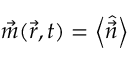Convert formula to latex. <formula><loc_0><loc_0><loc_500><loc_500>\vec { m } ( \vec { r } , t ) = \left < \hat { \vec { n } } \right ></formula> 